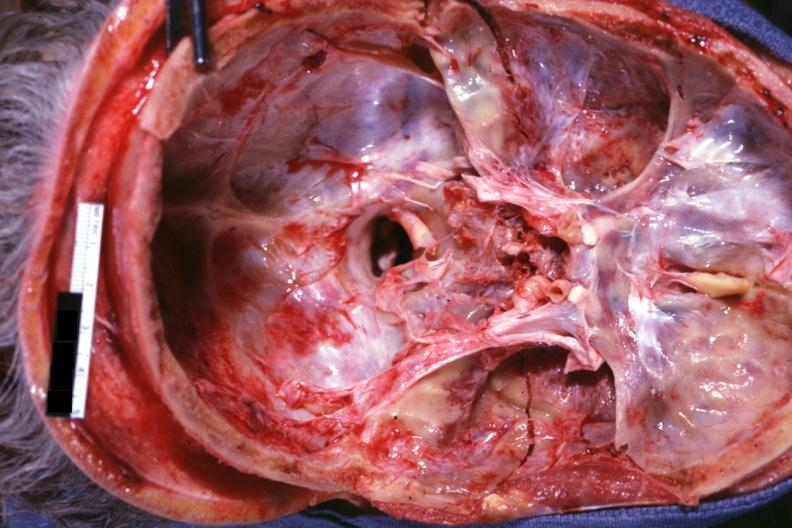what is present?
Answer the question using a single word or phrase. Bone 